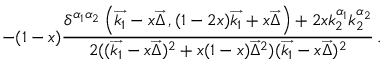<formula> <loc_0><loc_0><loc_500><loc_500>- ( 1 - x ) \frac { \delta ^ { \alpha _ { 1 } \alpha _ { 2 } } \left ( \overrightarrow { k _ { 1 } } - x \overrightarrow { \Delta } \, , ( 1 - 2 x ) \overrightarrow { k _ { 1 } } + x \overrightarrow { \Delta } \right ) + 2 x k _ { 2 } ^ { \alpha _ { 1 } } k _ { 2 } ^ { \alpha _ { 2 } } } { 2 ( ( \overrightarrow { k _ { 1 } } - x \overrightarrow { \Delta } ) ^ { 2 } + x ( 1 - x ) \overrightarrow { \Delta } ^ { 2 } ) ( \overrightarrow { k _ { 1 } } - x \overrightarrow { \Delta } ) ^ { 2 } } \, .</formula> 